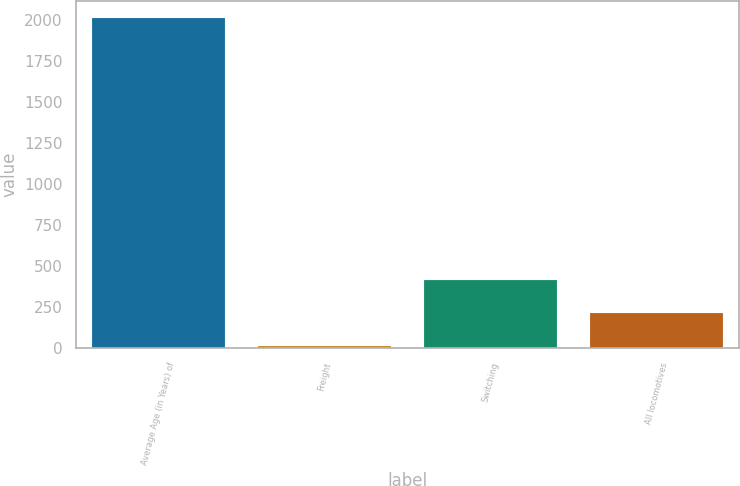Convert chart to OTSL. <chart><loc_0><loc_0><loc_500><loc_500><bar_chart><fcel>Average Age (in Years) of<fcel>Freight<fcel>Switching<fcel>All locomotives<nl><fcel>2014<fcel>13.9<fcel>413.92<fcel>213.91<nl></chart> 